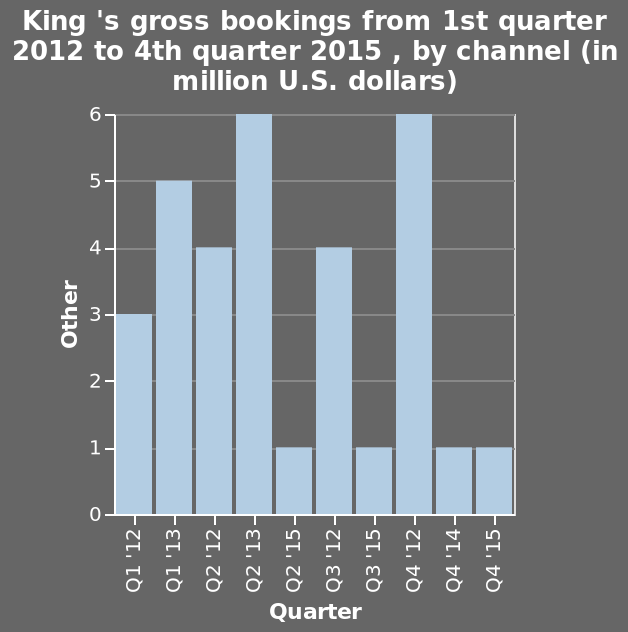<image>
What time period does the bar graph cover? The bar graph covers the time period from 1st quarter 2012 to 4th quarter 2015. What is the trend in bookings for Q1 from 2012 to 2013?  There is an increase in bookings from 3 million dollars (m$) in 2012 to 5 million dollars (m$) in 2013 for Q1. 